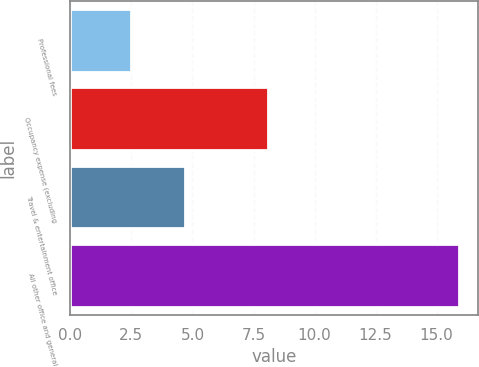Convert chart. <chart><loc_0><loc_0><loc_500><loc_500><bar_chart><fcel>Professional fees<fcel>Occupancy expense (excluding<fcel>Travel & entertainment office<fcel>All other office and general<nl><fcel>2.5<fcel>8.1<fcel>4.7<fcel>15.9<nl></chart> 